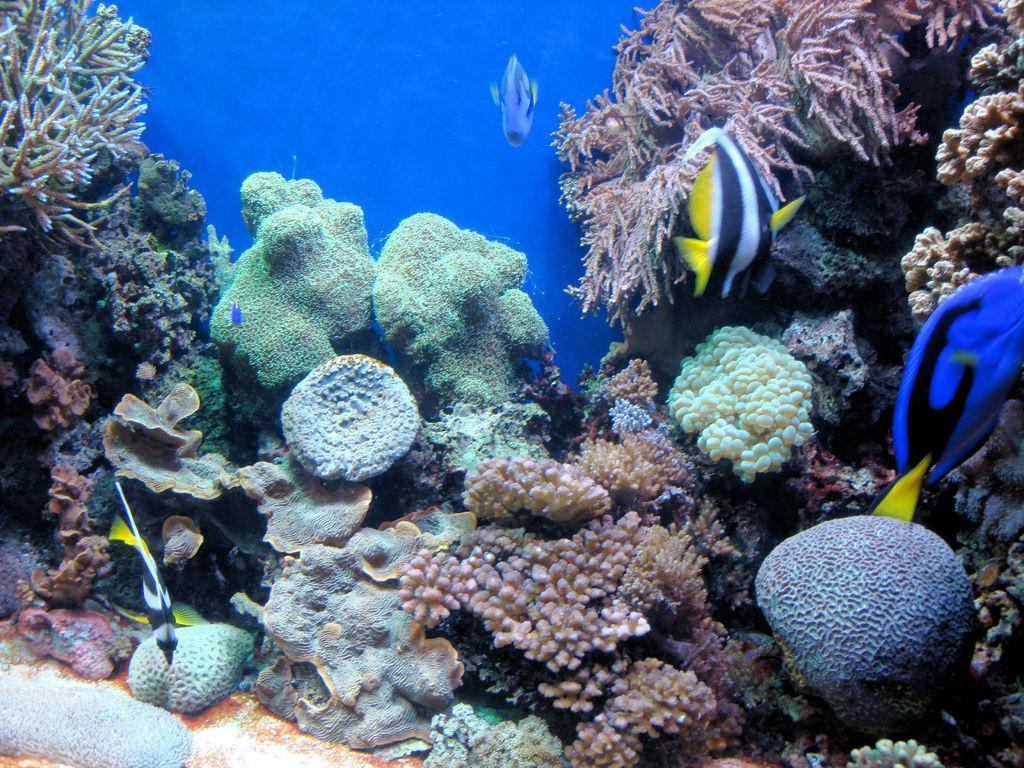What type of animals can be seen in the image? There are fishes in the image. What other living organisms are present in the image? There are sea plants in the image. What color is the background of the image? The background of the image is blue. What type of pies can be seen in the image? There are no pies present in the image; it features fishes and sea plants in a blue background. What type of vessel is used to transport the sea creatures in the image? There is no vessel present in the image; it is a still image of fishes and sea plants in a blue background. 